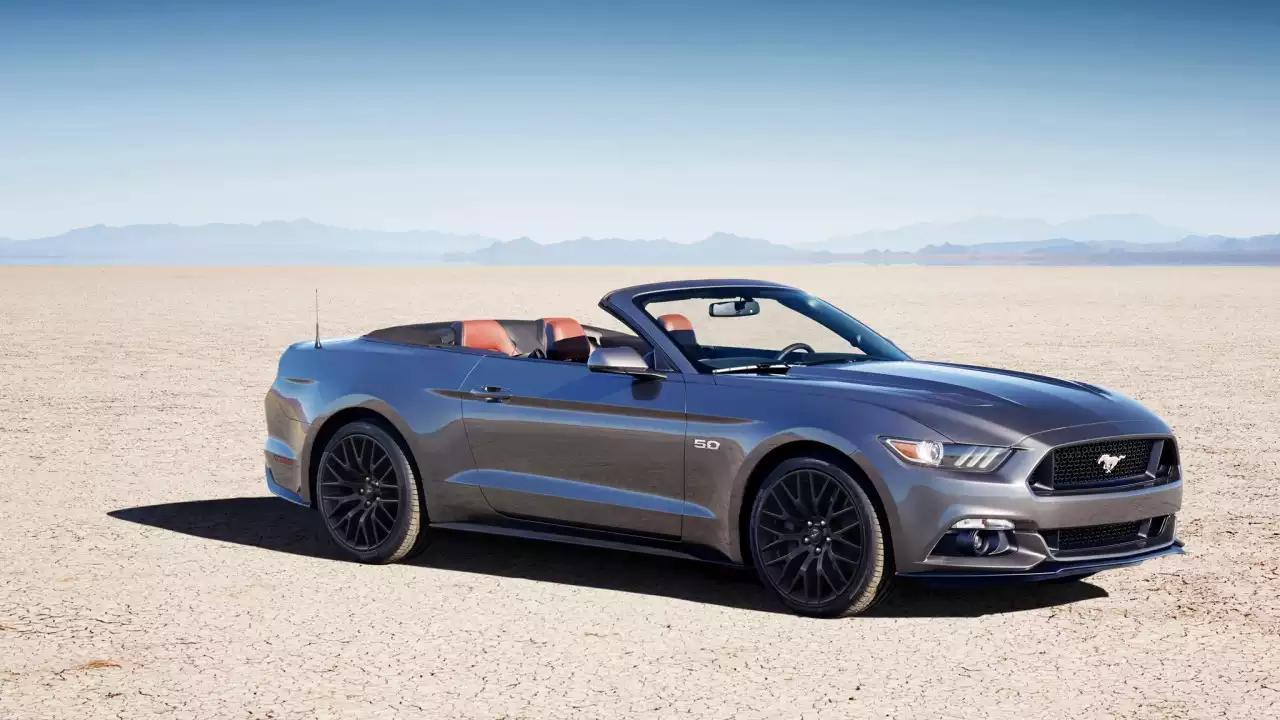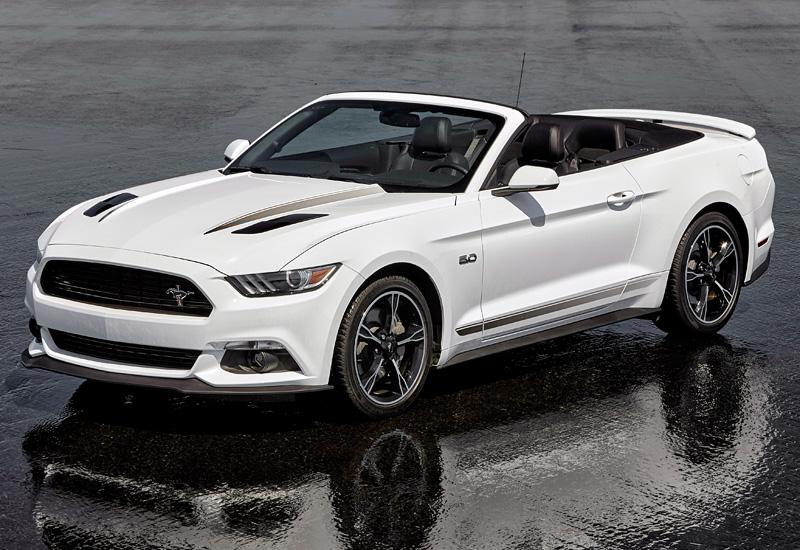The first image is the image on the left, the second image is the image on the right. Considering the images on both sides, is "One Ford Mustang is parked in dirt." valid? Answer yes or no. Yes. The first image is the image on the left, the second image is the image on the right. For the images displayed, is the sentence "a convertible mustang is parked on a sandy beach" factually correct? Answer yes or no. Yes. 